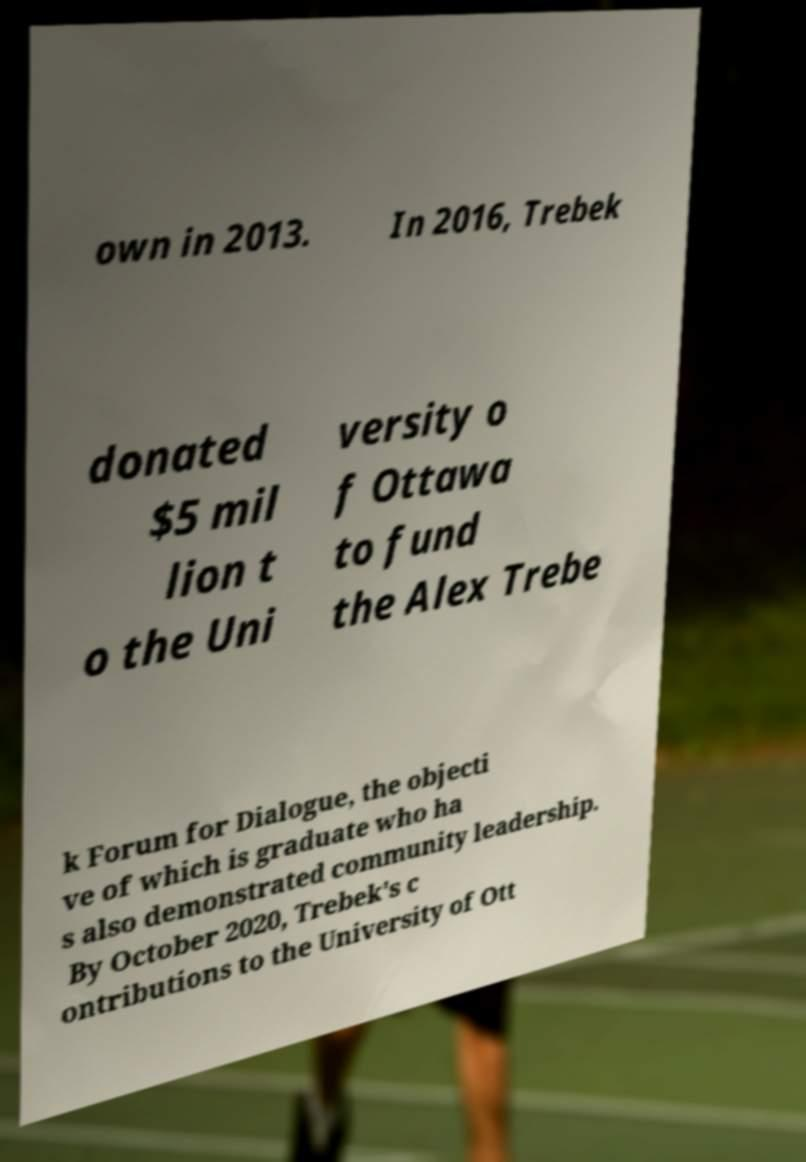Could you extract and type out the text from this image? own in 2013. In 2016, Trebek donated $5 mil lion t o the Uni versity o f Ottawa to fund the Alex Trebe k Forum for Dialogue, the objecti ve of which is graduate who ha s also demonstrated community leadership. By October 2020, Trebek's c ontributions to the University of Ott 